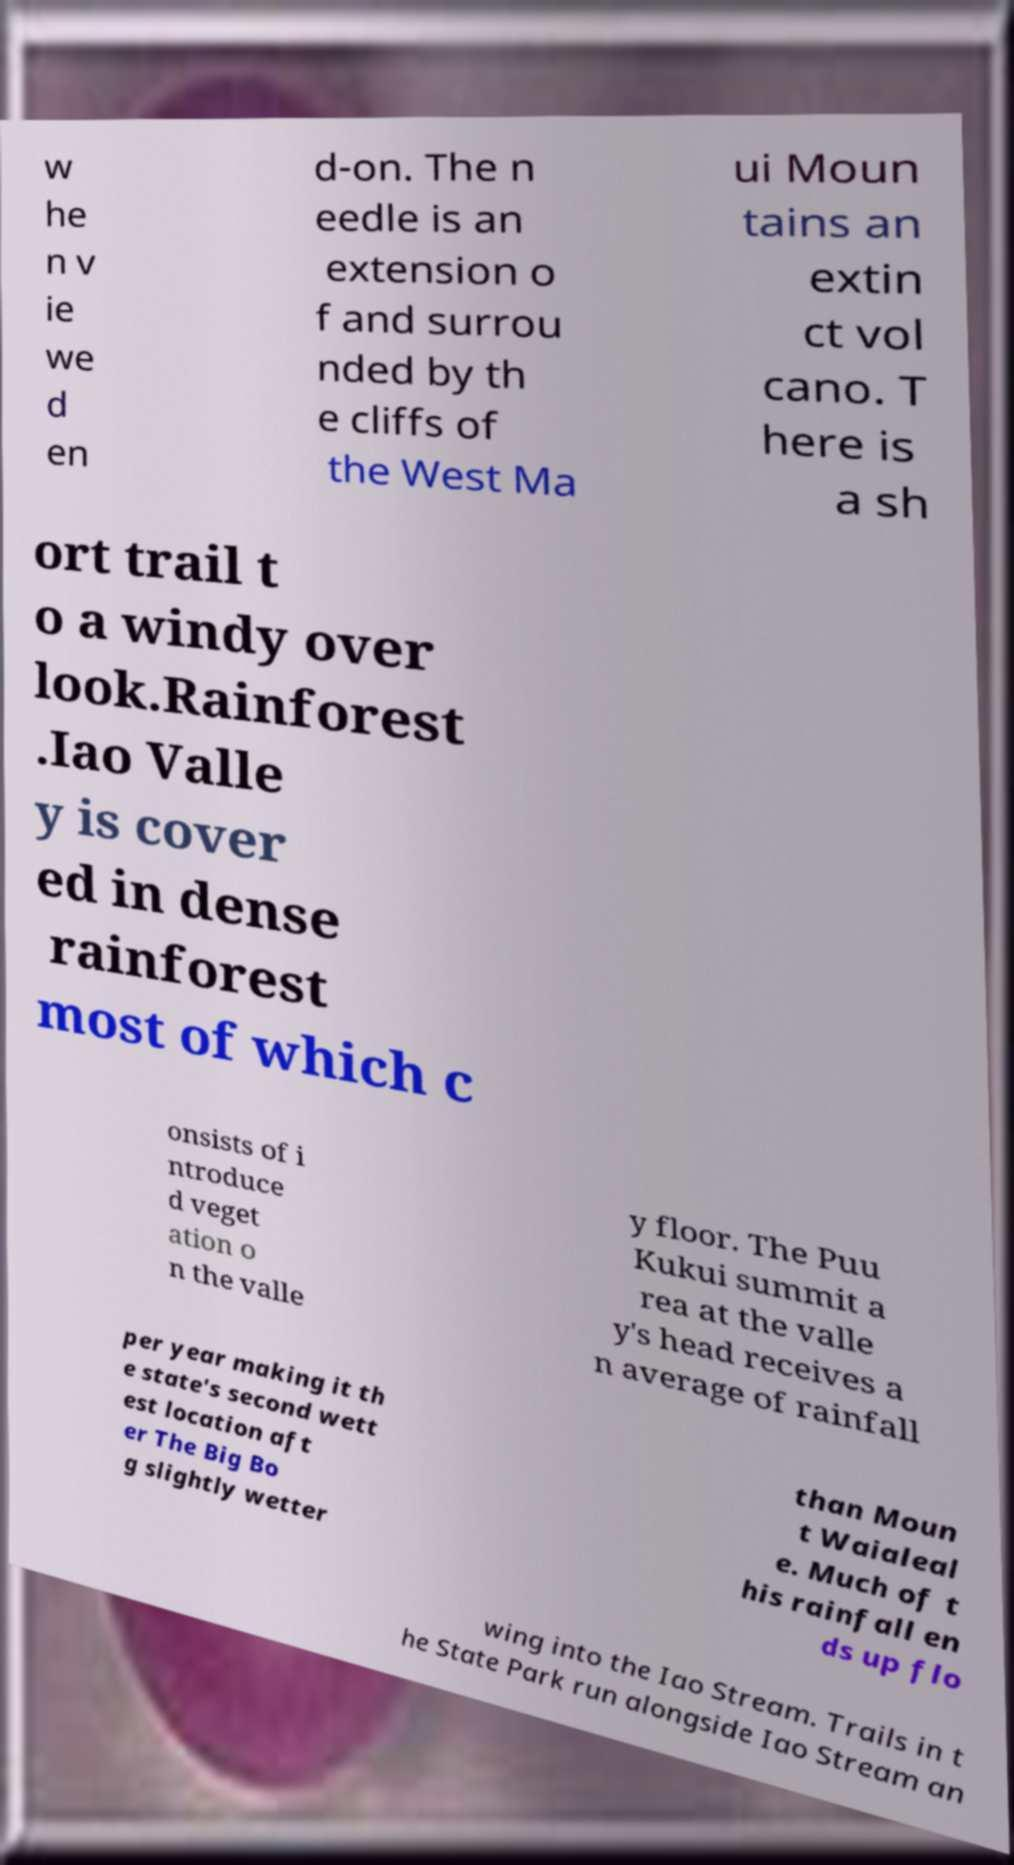Could you extract and type out the text from this image? w he n v ie we d en d-on. The n eedle is an extension o f and surrou nded by th e cliffs of the West Ma ui Moun tains an extin ct vol cano. T here is a sh ort trail t o a windy over look.Rainforest .Iao Valle y is cover ed in dense rainforest most of which c onsists of i ntroduce d veget ation o n the valle y floor. The Puu Kukui summit a rea at the valle y's head receives a n average of rainfall per year making it th e state's second wett est location aft er The Big Bo g slightly wetter than Moun t Waialeal e. Much of t his rainfall en ds up flo wing into the Iao Stream. Trails in t he State Park run alongside Iao Stream an 